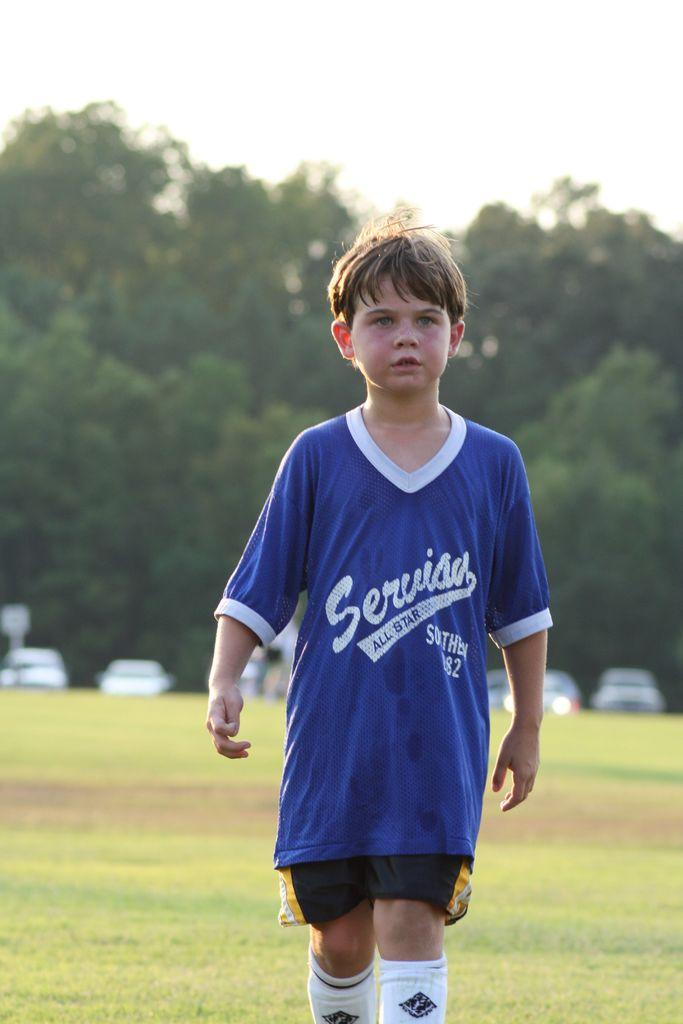<image>
Present a compact description of the photo's key features. A child is wearing a blue jersey, representing the Serviau All-Stars. 